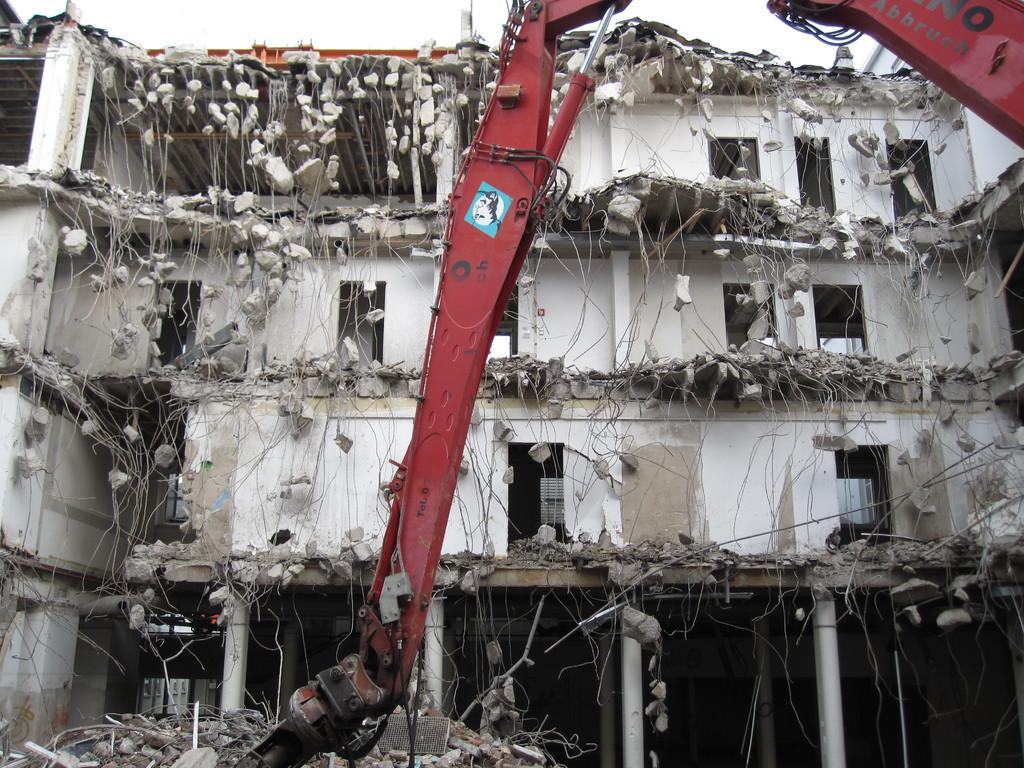What is the main subject of the image? The main subject of the image is a collapsed building. Are there any other objects or vehicles in the image? Yes, there is a vehicle in the image. What can be seen in the background of the image? The sky is visible in the background of the image. What type of root can be seen growing from the collapsed building in the image? There is no root growing from the collapsed building in the image. How does the spy use the vehicle in the image? There is no spy present in the image, so it is not possible to determine how a spy might use the vehicle. 